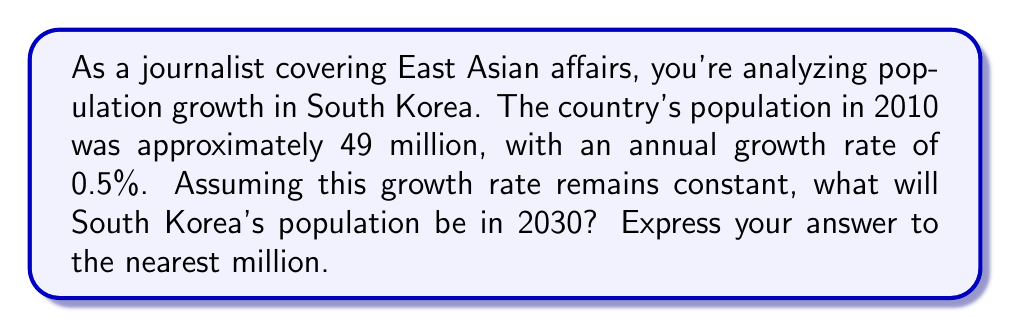Could you help me with this problem? Let's approach this step-by-step using an exponential function:

1) The exponential growth formula is:
   $$ P(t) = P_0 \cdot e^{rt} $$
   Where:
   $P(t)$ is the population at time $t$
   $P_0$ is the initial population
   $r$ is the growth rate
   $t$ is the time in years

2) We know:
   $P_0 = 49$ million (in 2010)
   $r = 0.005$ (0.5% annual growth rate)
   $t = 20$ years (from 2010 to 2030)

3) Plugging these values into our formula:
   $$ P(20) = 49 \cdot e^{0.005 \cdot 20} $$

4) Simplify the exponent:
   $$ P(20) = 49 \cdot e^{0.1} $$

5) Calculate:
   $$ P(20) = 49 \cdot 1.10517 $$
   $$ P(20) = 54.15333 $$

6) Rounding to the nearest million:
   $$ P(20) \approx 54 \text{ million} $$

This analysis provides insight into South Korea's projected population growth, which could be valuable for your reporting on demographic trends in East Asia.
Answer: 54 million 